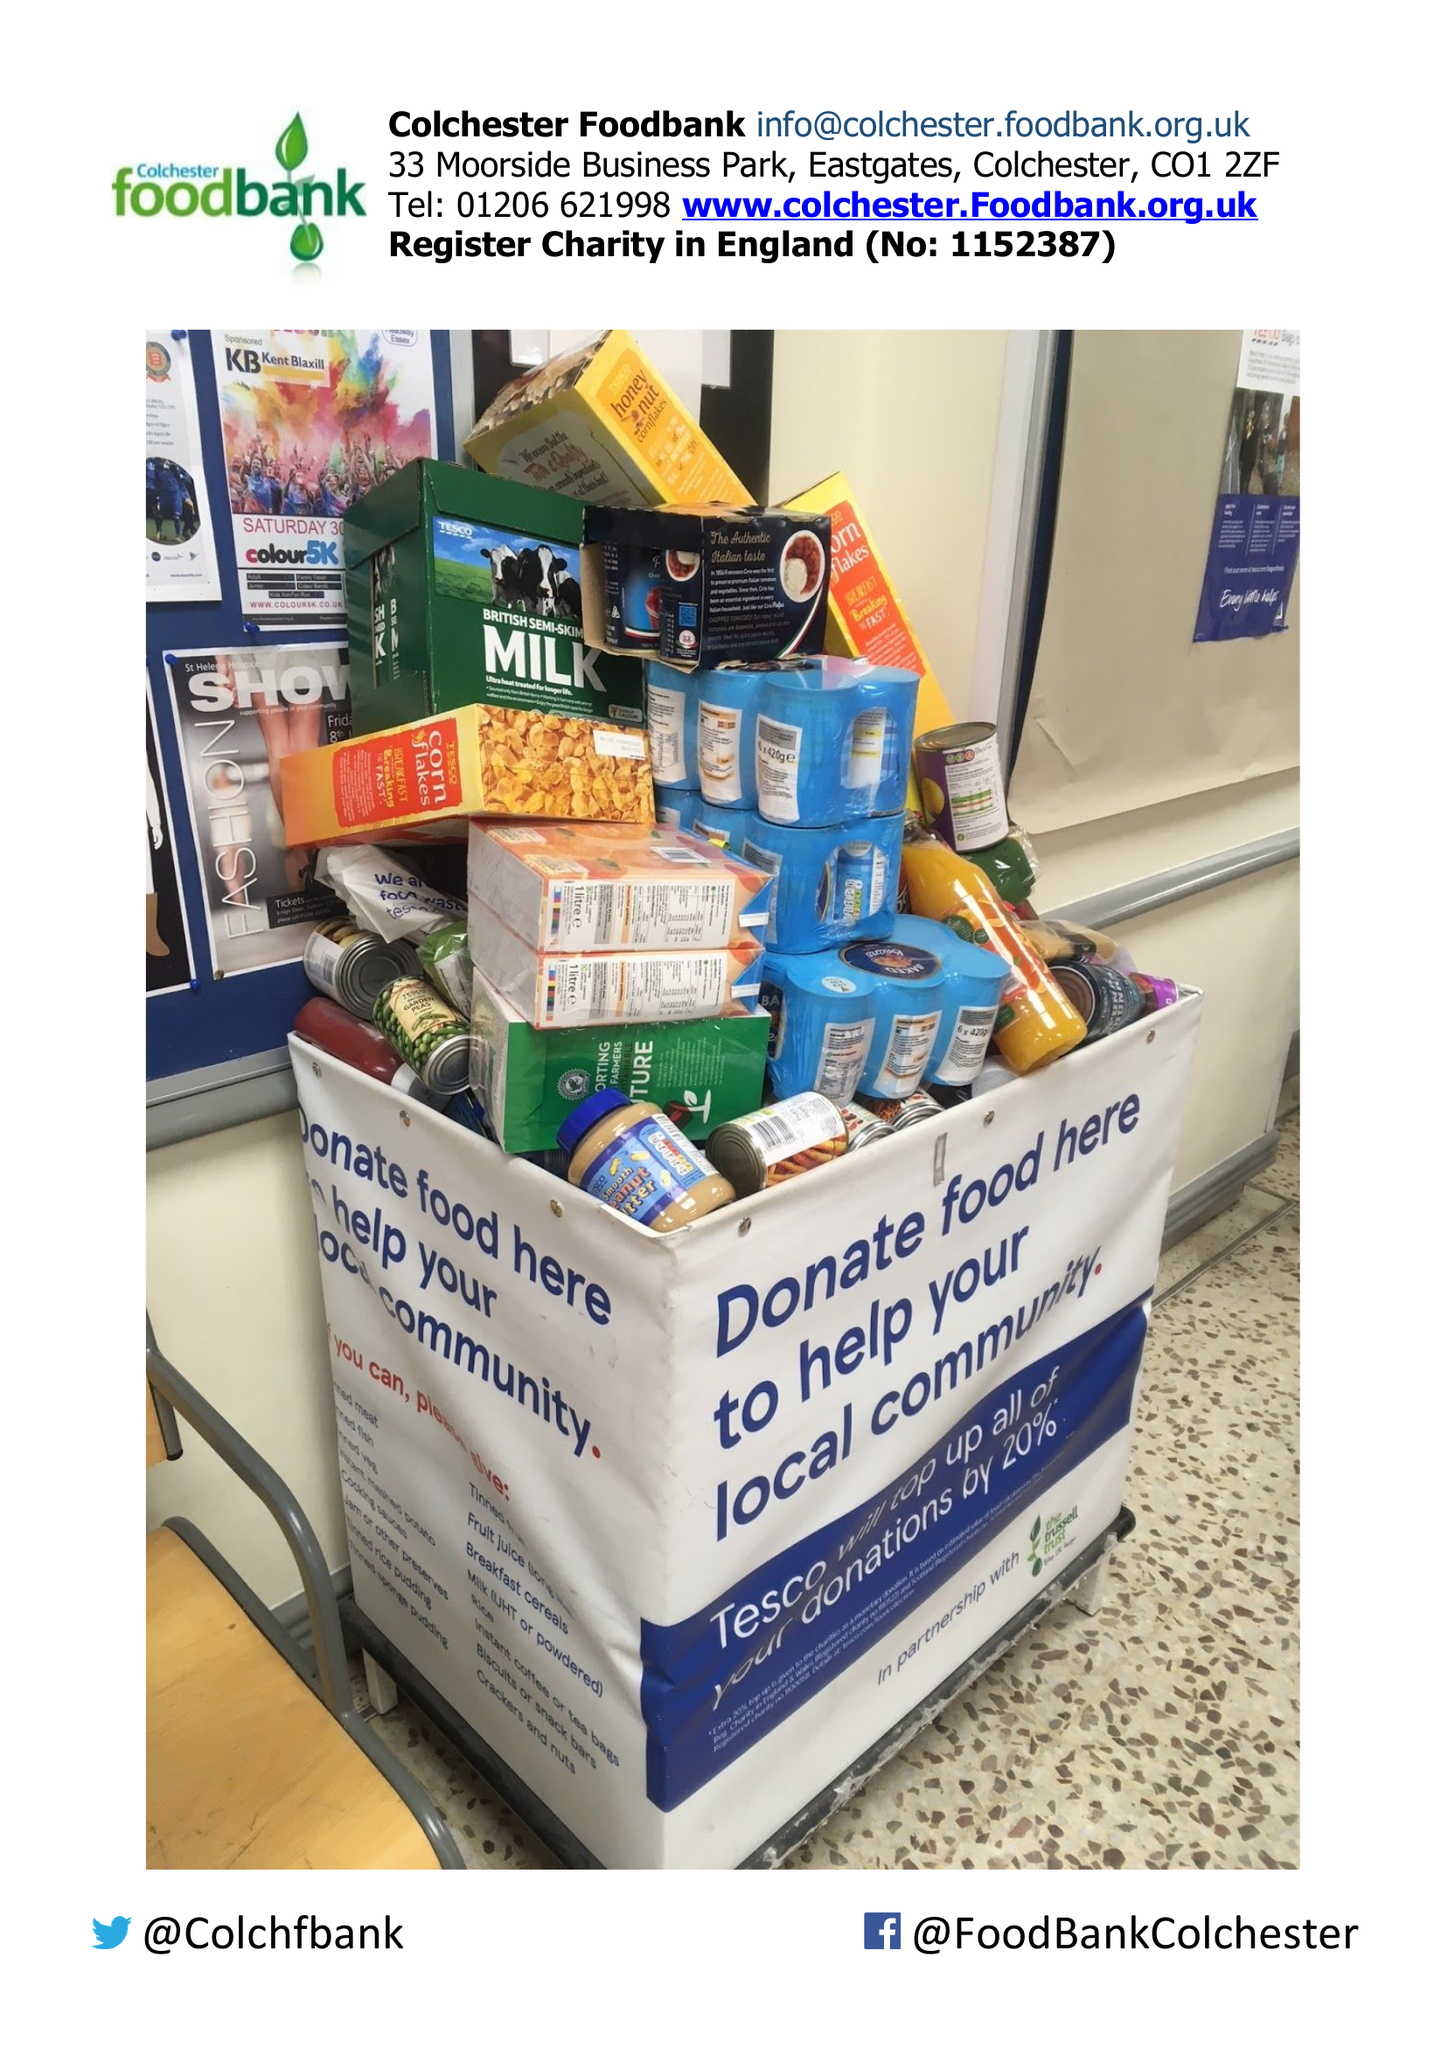What is the value for the income_annually_in_british_pounds?
Answer the question using a single word or phrase. 36788.00 